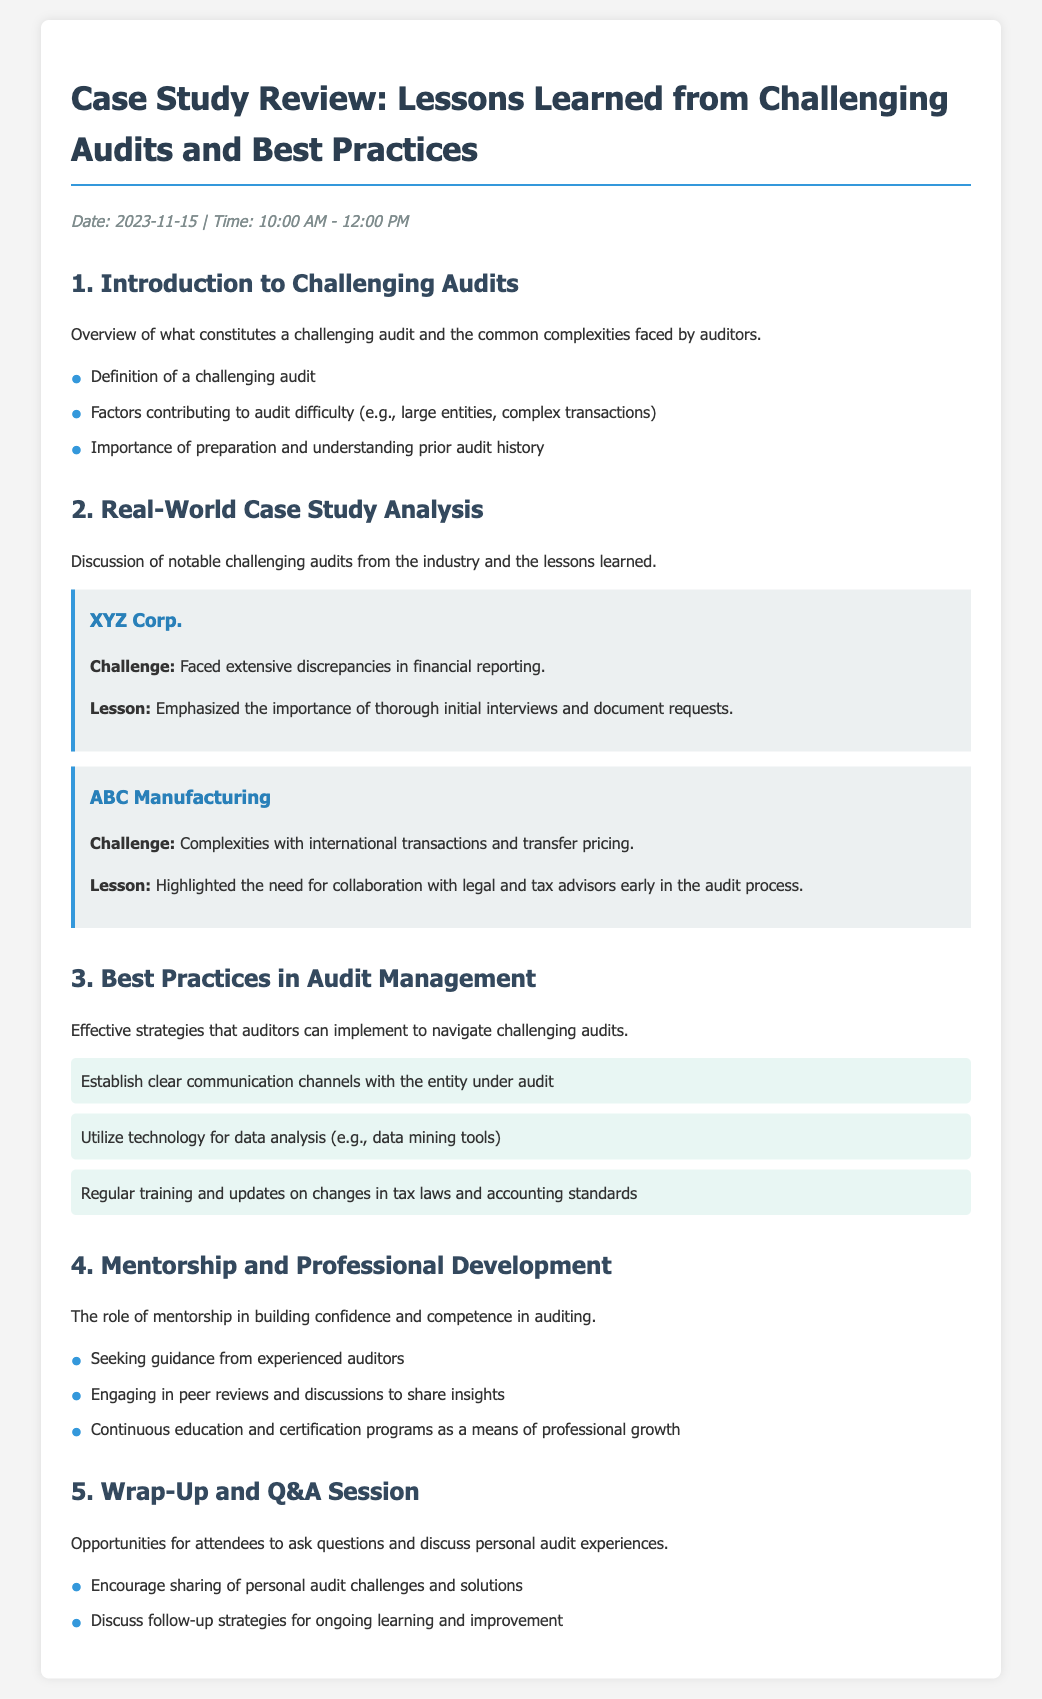what is the date of the event? The date of the event is specified in the document under the date-time section.
Answer: 2023-11-15 what are the common factors contributing to audit difficulty? This information is listed under the introduction section, detailing various factors.
Answer: Large entities, complex transactions what is the first case study mentioned in the document? The first case study listed in the real-world case study analysis section pertains to a specific company.
Answer: XYZ Corp what is a listed lesson from the ABC Manufacturing case study? The lesson is found in the description of the challenges faced by ABC Manufacturing.
Answer: Collaboration with legal and tax advisors how many best practices are mentioned in the audit management section? The number of best practices is countable in the corresponding section of the document.
Answer: Three what is suggested for professional development? Suggestions for professional development are provided in the mentorship section, highlighting different practices.
Answer: Continuous education and certification programs what is the role of mentorship according to the document? The content under mentorship and professional development outlines the importance of mentorship.
Answer: Building confidence and competence what opportunity is provided at the end of the agenda? This information is found in the wrap-up section, detailing what attendees can expect.
Answer: Q&A Session 